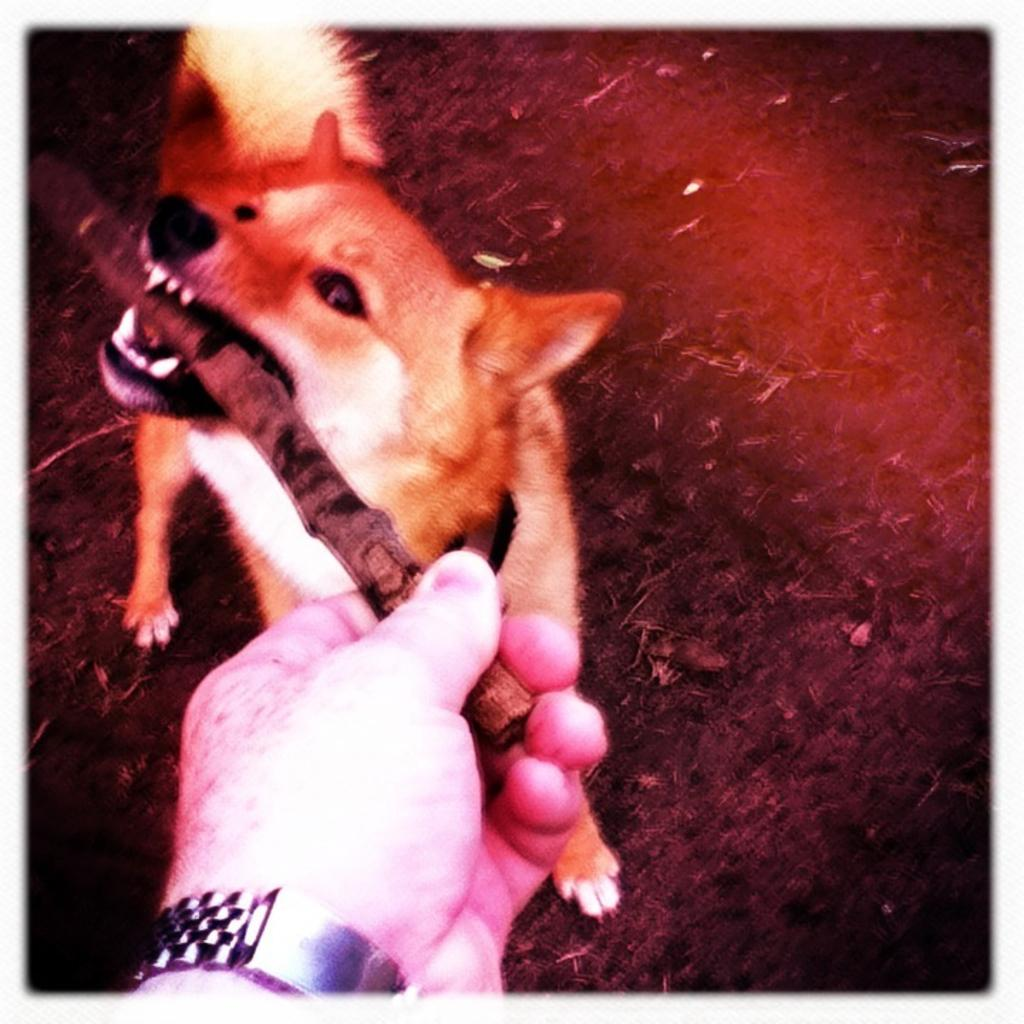What type of animal is in the image? There is a dog in the image. What is the person's hand holding in the image? A person's hand is holding a stick in the image. What is the name of the dog in the image? The name of the dog is not mentioned in the image, so it cannot be determined. What is the rate of the dog's heartbeat in the image? The dog's heartbeat is not visible or measurable in the image, so it cannot be determined. 